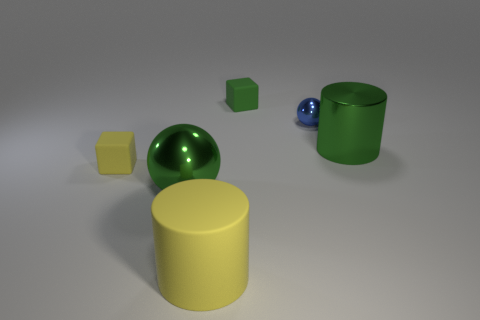How do the colors and materials of these objects contribute to their appearance? The objects display a matte finish with solid, uniform colors that give them a simplistic yet visually appealing aspect. The reflected light on their surfaces indicates that the material could be plastic or some kind of polished stone, contributing to a sense of smoothness and solidity. The colors—yellow, green, and blue—are primary and secondary colors that provide an interesting contrast when viewed together, enhancing their individual presence within the scene. 